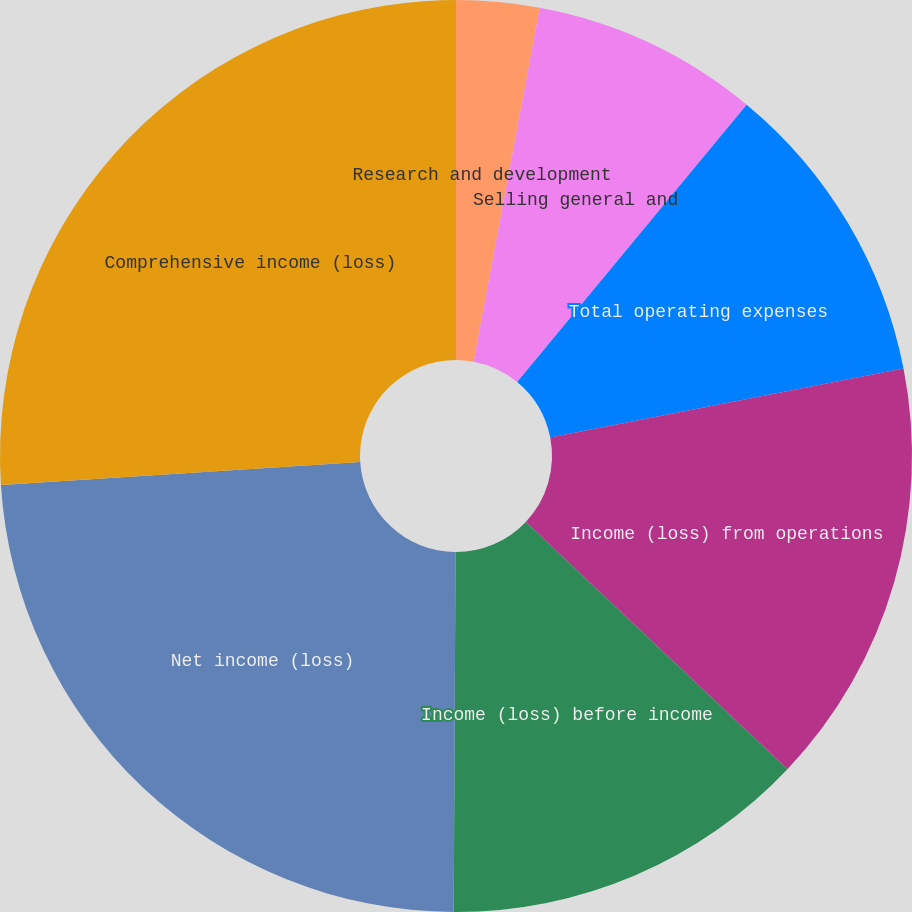Convert chart to OTSL. <chart><loc_0><loc_0><loc_500><loc_500><pie_chart><fcel>Research and development<fcel>Selling general and<fcel>Total operating expenses<fcel>Income (loss) from operations<fcel>Income (loss) before income<fcel>Net income (loss)<fcel>Comprehensive income (loss)<nl><fcel>2.94%<fcel>8.06%<fcel>10.93%<fcel>15.12%<fcel>13.03%<fcel>23.91%<fcel>26.01%<nl></chart> 